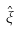<formula> <loc_0><loc_0><loc_500><loc_500>\hat { \xi }</formula> 